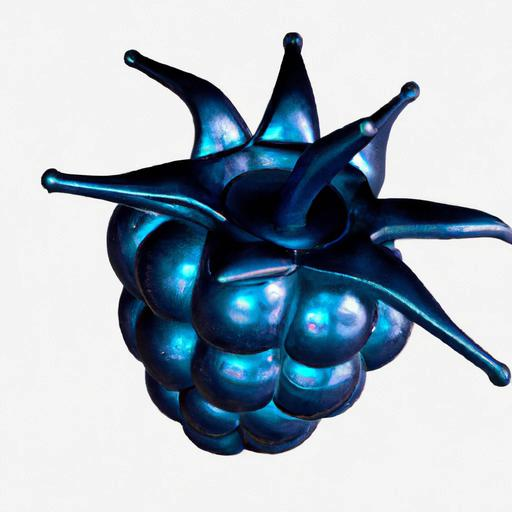Could this object exist in nature? It's unlikely for an object like this with such a pronounced metallic sheen and vibrant blue color to exist in nature. The image looks more like an artistic creation, blending familiar organic shapes with unnatural colors and textures for a visually striking effect. 